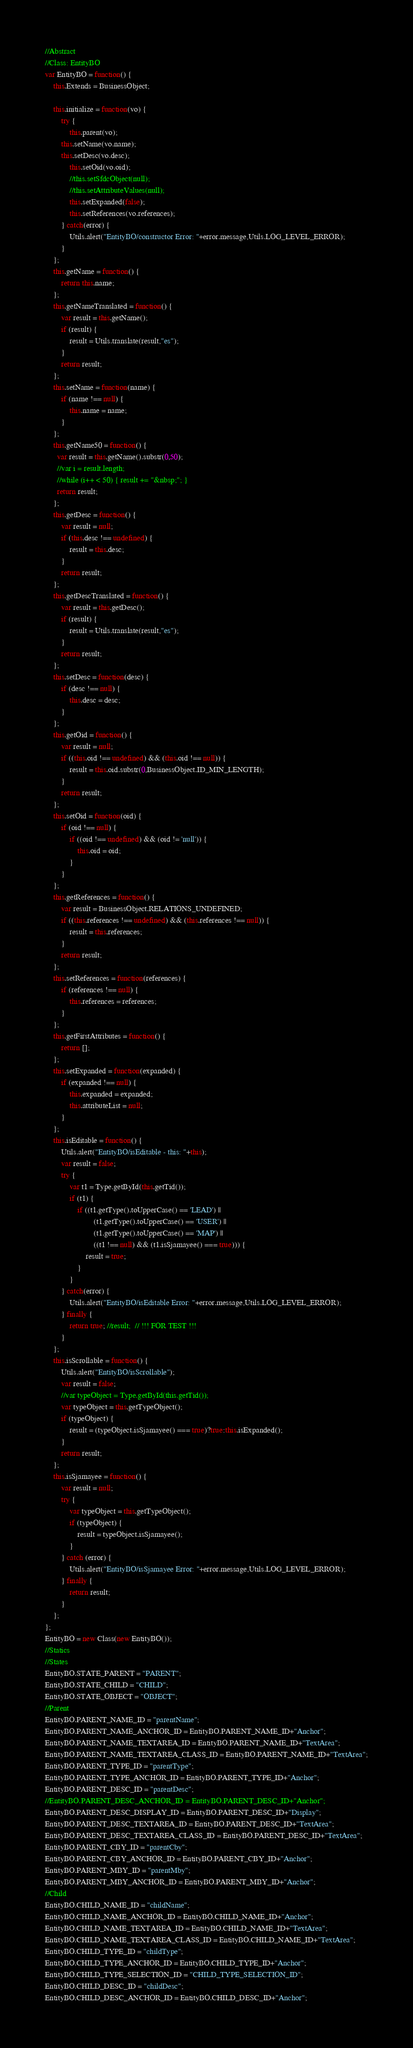Convert code to text. <code><loc_0><loc_0><loc_500><loc_500><_JavaScript_>//Abstract
//Class: EntityBO
var EntityBO = function() {
	this.Extends = BusinessObject;
	
	this.initialize = function(vo) {
		try {
			this.parent(vo);
  		this.setName(vo.name);
  		this.setDesc(vo.desc);
			this.setOid(vo.oid);
			//this.setSfdcObject(null);
			//this.setAttributeValues(null);
			this.setExpanded(false);
			this.setReferences(vo.references);
		} catch(error) {
			Utils.alert("EntityBO/constructor Error: "+error.message,Utils.LOG_LEVEL_ERROR);
		}
	};
	this.getName = function() {
		return this.name;
	};
	this.getNameTranslated = function() {
		var result = this.getName();
		if (result) {
			result = Utils.translate(result,"es");
		}
		return result;
	};
	this.setName = function(name) {
		if (name !== null) {
			this.name = name;
		}
	};
	this.getName50 = function() {
	  var result = this.getName().substr(0,50);
	  //var i = result.length;
	  //while (i++ < 50) { result += "&nbsp;"; }
	  return result;
	};
	this.getDesc = function() {
		var result = null;
		if (this.desc !== undefined) {
			result = this.desc;
		}
		return result;
	};
	this.getDescTranslated = function() {
		var result = this.getDesc();
		if (result) {
			result = Utils.translate(result,"es");
		}
		return result;
	};
	this.setDesc = function(desc) {
		if (desc !== null) {
			this.desc = desc;
		}
	};
	this.getOid = function() {
		var result = null;
		if ((this.oid !== undefined) && (this.oid !== null)) {
			result = this.oid.substr(0,BusinessObject.ID_MIN_LENGTH);
		}
		return result;
	};
	this.setOid = function(oid) {
		if (oid !== null) {
			if ((oid !== undefined) && (oid != 'null')) {
				this.oid = oid;
			}
		}
	};
	this.getReferences = function() {
		var result = BusinessObject.RELATIONS_UNDEFINED;
		if ((this.references !== undefined) && (this.references !== null)) {
			result = this.references;
		}
		return result;
	};
	this.setReferences = function(references) {
		if (references !== null) {
			this.references = references;
		}
	};
	this.getFirstAttributes = function() {
		return [];
	};
	this.setExpanded = function(expanded) {
		if (expanded !== null) {
			this.expanded = expanded;
			this.attributeList = null;
		}
	};
	this.isEditable = function() {
		Utils.alert("EntityBO/isEditable - this: "+this);
		var result = false;
		try {
			var t1 = Type.getById(this.getTid());
			if (t1) {
				if ((t1.getType().toUpperCase() == 'LEAD') ||
						(t1.getType().toUpperCase() == 'USER') ||
						(t1.getType().toUpperCase() == 'MAP') ||
						((t1 !== null) && (t1.isSjamayee() === true))) {
					result = true;
				}
			}
		} catch(error) {
			Utils.alert("EntityBO/isEditable Error: "+error.message,Utils.LOG_LEVEL_ERROR);
		} finally {
			return true; //result;  // !!! FOR TEST !!!
		}
	};
	this.isScrollable = function() {
		Utils.alert("EntityBO/isScrollable");
		var result = false;
		//var typeObject = Type.getById(this.getTid());
		var typeObject = this.getTypeObject();
		if (typeObject) {
			result = (typeObject.isSjamayee() === true)?true:this.isExpanded();
		}
		return result;
	};
	this.isSjamayee = function() {
		var result = null;
		try {
			var typeObject = this.getTypeObject();
			if (typeObject) {
				result = typeObject.isSjamayee();
			}
		} catch (error) {
			Utils.alert("EntityBO/isSjamayee Error: "+error.message,Utils.LOG_LEVEL_ERROR);
		} finally {
			return result;
		}
	};
};
EntityBO = new Class(new EntityBO());
//Statics
//States
EntityBO.STATE_PARENT = "PARENT";
EntityBO.STATE_CHILD = "CHILD";
EntityBO.STATE_OBJECT = "OBJECT";
//Parent
EntityBO.PARENT_NAME_ID = "parentName";
EntityBO.PARENT_NAME_ANCHOR_ID = EntityBO.PARENT_NAME_ID+"Anchor";
EntityBO.PARENT_NAME_TEXTAREA_ID = EntityBO.PARENT_NAME_ID+"TextArea";
EntityBO.PARENT_NAME_TEXTAREA_CLASS_ID = EntityBO.PARENT_NAME_ID+"TextArea";
EntityBO.PARENT_TYPE_ID = "parentType";
EntityBO.PARENT_TYPE_ANCHOR_ID = EntityBO.PARENT_TYPE_ID+"Anchor";
EntityBO.PARENT_DESC_ID = "parentDesc";
//EntityBO.PARENT_DESC_ANCHOR_ID = EntityBO.PARENT_DESC_ID+"Anchor";
EntityBO.PARENT_DESC_DISPLAY_ID = EntityBO.PARENT_DESC_ID+"Display";
EntityBO.PARENT_DESC_TEXTAREA_ID = EntityBO.PARENT_DESC_ID+"TextArea";
EntityBO.PARENT_DESC_TEXTAREA_CLASS_ID = EntityBO.PARENT_DESC_ID+"TextArea";
EntityBO.PARENT_CBY_ID = "parentCby";
EntityBO.PARENT_CBY_ANCHOR_ID = EntityBO.PARENT_CBY_ID+"Anchor";
EntityBO.PARENT_MBY_ID = "parentMby";
EntityBO.PARENT_MBY_ANCHOR_ID = EntityBO.PARENT_MBY_ID+"Anchor";
//Child
EntityBO.CHILD_NAME_ID = "childName";
EntityBO.CHILD_NAME_ANCHOR_ID = EntityBO.CHILD_NAME_ID+"Anchor";
EntityBO.CHILD_NAME_TEXTAREA_ID = EntityBO.CHILD_NAME_ID+"TextArea";
EntityBO.CHILD_NAME_TEXTAREA_CLASS_ID = EntityBO.CHILD_NAME_ID+"TextArea";
EntityBO.CHILD_TYPE_ID = "childType";
EntityBO.CHILD_TYPE_ANCHOR_ID = EntityBO.CHILD_TYPE_ID+"Anchor";
EntityBO.CHILD_TYPE_SELECTION_ID = "CHILD_TYPE_SELECTION_ID";
EntityBO.CHILD_DESC_ID = "childDesc";
EntityBO.CHILD_DESC_ANCHOR_ID = EntityBO.CHILD_DESC_ID+"Anchor";</code> 